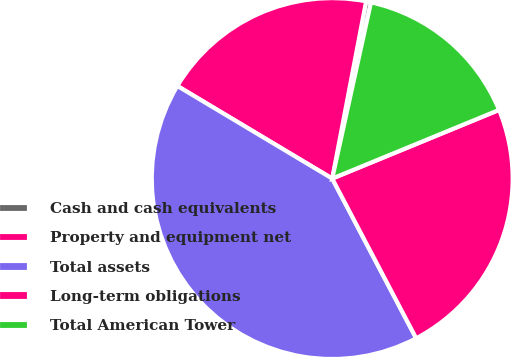Convert chart. <chart><loc_0><loc_0><loc_500><loc_500><pie_chart><fcel>Cash and cash equivalents<fcel>Property and equipment net<fcel>Total assets<fcel>Long-term obligations<fcel>Total American Tower<nl><fcel>0.44%<fcel>19.43%<fcel>41.28%<fcel>23.51%<fcel>15.34%<nl></chart> 